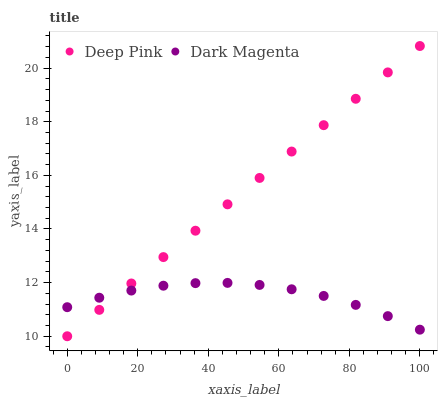Does Dark Magenta have the minimum area under the curve?
Answer yes or no. Yes. Does Deep Pink have the maximum area under the curve?
Answer yes or no. Yes. Does Dark Magenta have the maximum area under the curve?
Answer yes or no. No. Is Deep Pink the smoothest?
Answer yes or no. Yes. Is Dark Magenta the roughest?
Answer yes or no. Yes. Is Dark Magenta the smoothest?
Answer yes or no. No. Does Deep Pink have the lowest value?
Answer yes or no. Yes. Does Dark Magenta have the lowest value?
Answer yes or no. No. Does Deep Pink have the highest value?
Answer yes or no. Yes. Does Dark Magenta have the highest value?
Answer yes or no. No. Does Deep Pink intersect Dark Magenta?
Answer yes or no. Yes. Is Deep Pink less than Dark Magenta?
Answer yes or no. No. Is Deep Pink greater than Dark Magenta?
Answer yes or no. No. 